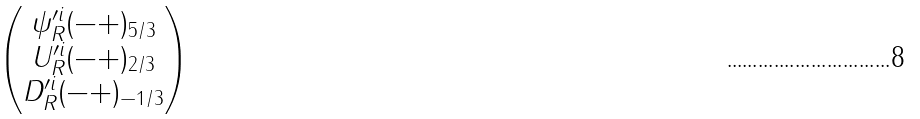<formula> <loc_0><loc_0><loc_500><loc_500>\begin{pmatrix} \psi ^ { \prime i } _ { R } ( - + ) _ { 5 / 3 } \\ U ^ { \prime i } _ { R } ( - + ) _ { 2 / 3 } \\ D ^ { \prime i } _ { R } ( - + ) _ { - 1 / 3 } \end{pmatrix}</formula> 